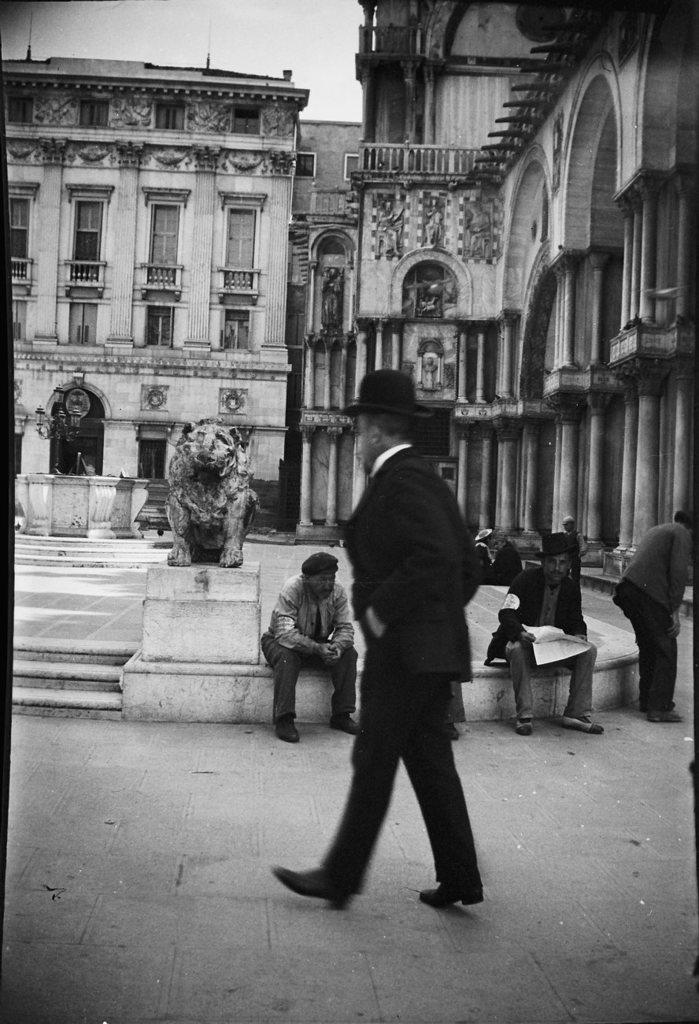What is the main subject of the image? There is a man walking in the center of the image. What are the people in the background doing? The people in the background are sitting. What other object can be seen in the image besides the man and the people? There is a statue in the image. What can be seen in the distance in the image? There are buildings visible in the background. What is visible at the top of the image? The sky is visible at the top of the image. How many bikes are being washed in the image? There are no bikes or washing activities present in the image. What type of oil can be seen dripping from the statue in the image? There is no oil present in the image, and the statue does not appear to be dripping anything. 